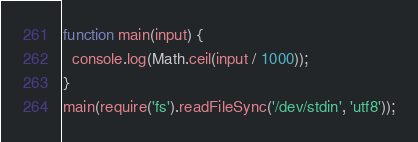Convert code to text. <code><loc_0><loc_0><loc_500><loc_500><_JavaScript_>function main(input) {
  console.log(Math.ceil(input / 1000));
}
main(require('fs').readFileSync('/dev/stdin', 'utf8'));</code> 